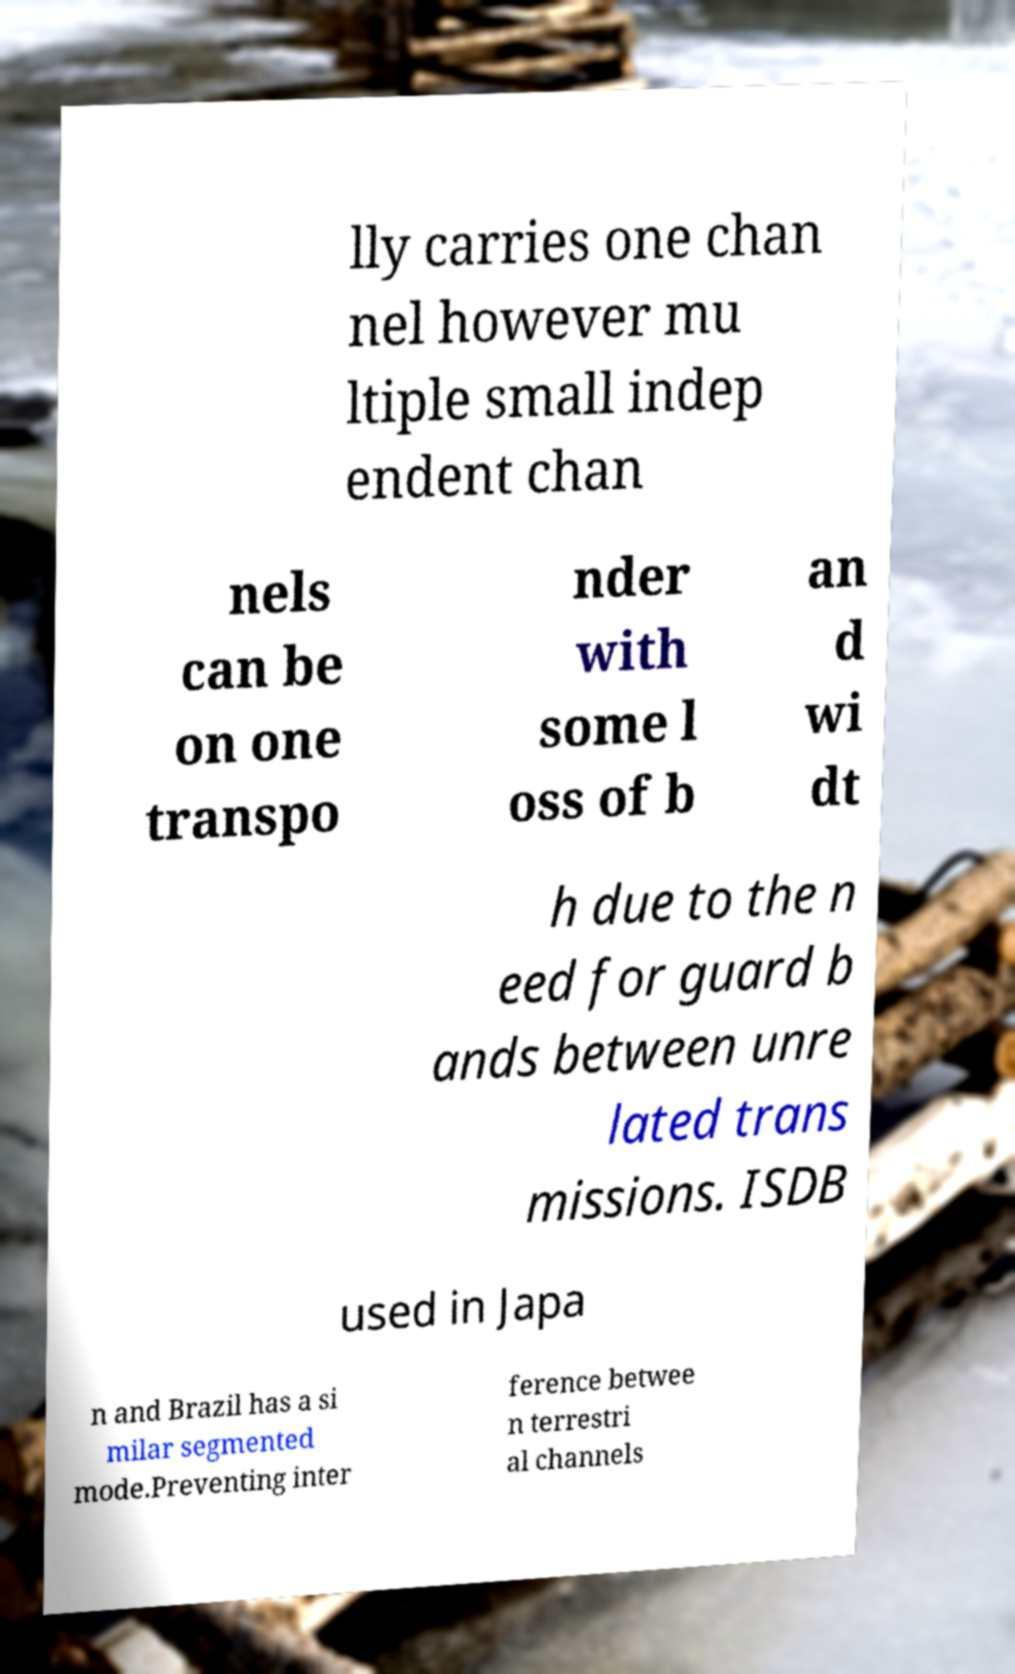Please read and relay the text visible in this image. What does it say? lly carries one chan nel however mu ltiple small indep endent chan nels can be on one transpo nder with some l oss of b an d wi dt h due to the n eed for guard b ands between unre lated trans missions. ISDB used in Japa n and Brazil has a si milar segmented mode.Preventing inter ference betwee n terrestri al channels 